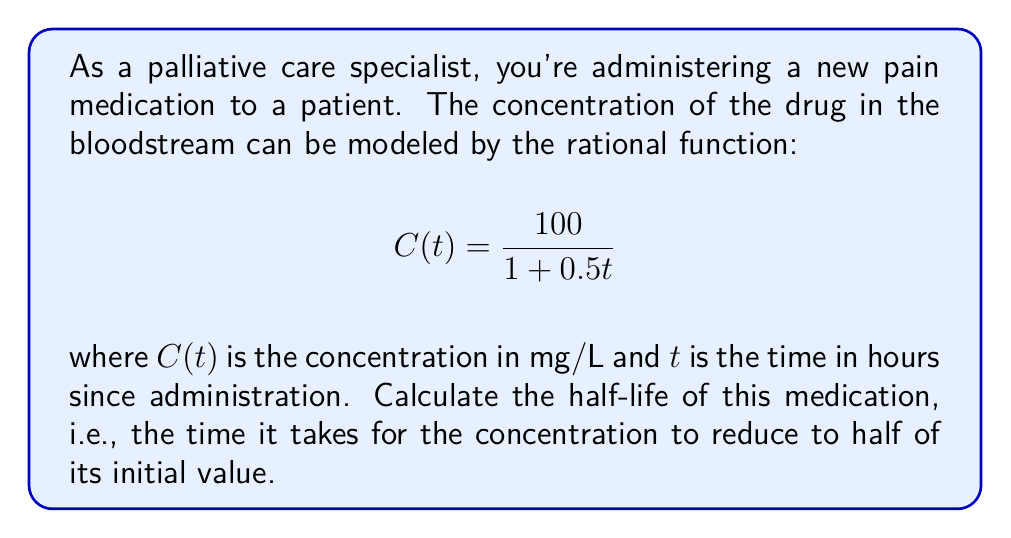Help me with this question. To solve this problem, we'll follow these steps:

1) First, let's determine the initial concentration at $t = 0$:
   $$C(0) = \frac{100}{1 + 0.5(0)} = \frac{100}{1} = 100 \text{ mg/L}$$

2) The half-life is when the concentration is half of this initial value:
   $$C(t_{1/2}) = \frac{100}{2} = 50 \text{ mg/L}$$

3) Now, we can set up an equation:
   $$\frac{100}{1 + 0.5t_{1/2}} = 50$$

4) Multiply both sides by $(1 + 0.5t_{1/2})$:
   $$100 = 50(1 + 0.5t_{1/2})$$

5) Distribute on the right side:
   $$100 = 50 + 25t_{1/2}$$

6) Subtract 50 from both sides:
   $$50 = 25t_{1/2}$$

7) Divide both sides by 25:
   $$t_{1/2} = \frac{50}{25} = 2$$

Therefore, the half-life of the medication is 2 hours.
Answer: 2 hours 